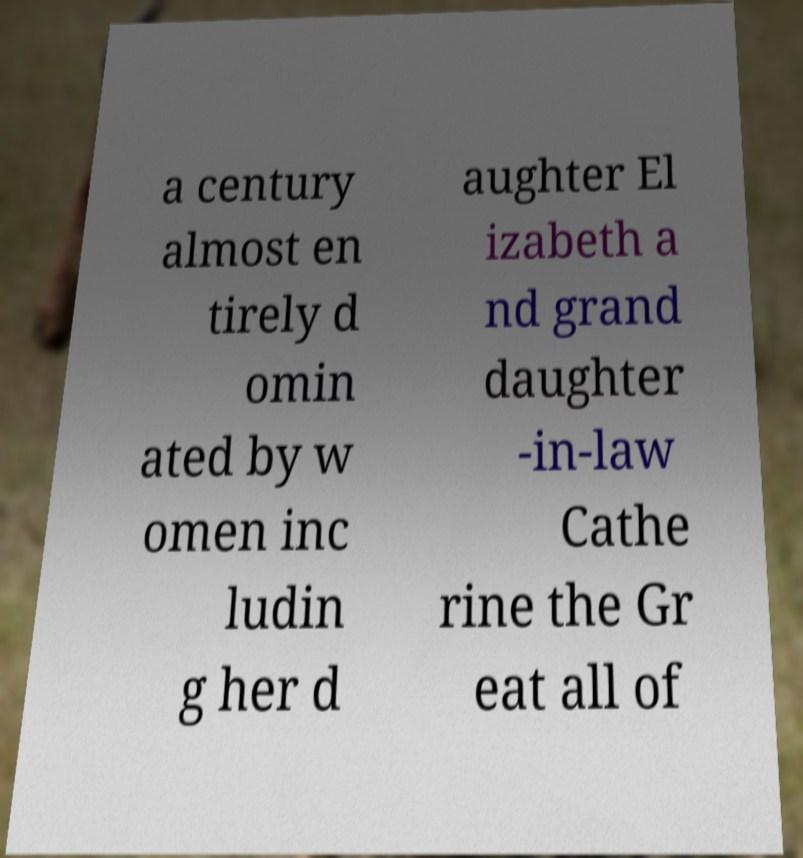For documentation purposes, I need the text within this image transcribed. Could you provide that? a century almost en tirely d omin ated by w omen inc ludin g her d aughter El izabeth a nd grand daughter -in-law Cathe rine the Gr eat all of 